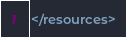<code> <loc_0><loc_0><loc_500><loc_500><_XML_></resources>
</code> 